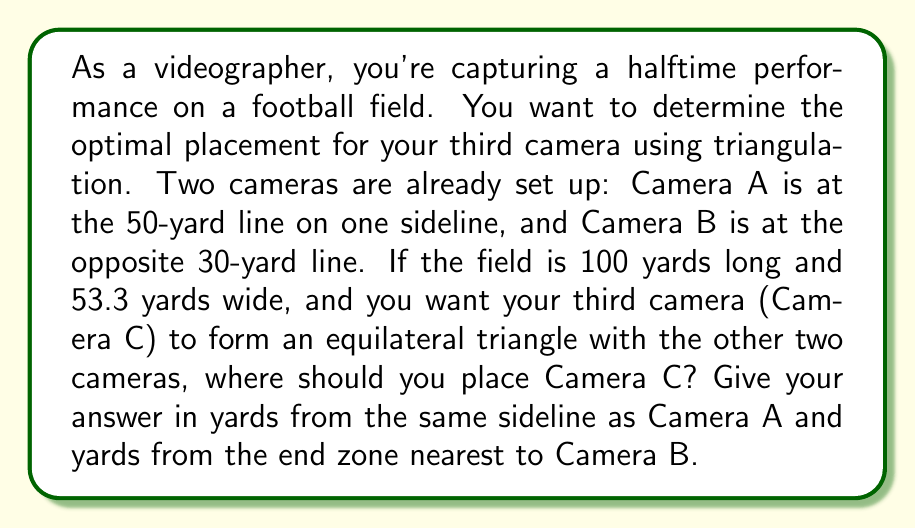Can you solve this math problem? Let's approach this step-by-step:

1) First, let's visualize the field and the cameras:

[asy]
unitsize(2.5mm);
draw((0,0)--(100,0)--(100,53.3)--(0,53.3)--cycle);
dot((50,0),red);
label("A",(50,0),S);
dot((70,53.3),red);
label("B",(70,53.3),N);
[/asy]

2) We need to find the distance between Camera A and Camera B. We can use the Pythagorean theorem:
   $$d = \sqrt{(70-50)^2 + 53.3^2} = \sqrt{400 + 2840.89} = \sqrt{3240.89} \approx 56.93$$yards

3) Since we want an equilateral triangle, Camera C should be the same distance from both A and B.

4) The perpendicular bisector of line AB will intersect the sideline at the point where Camera C should be placed.

5) Let's find the midpoint of AB:
   x-coordinate: $(50 + 70) / 2 = 60$
   y-coordinate: $(0 + 53.3) / 2 = 26.65$

6) The slope of AB is:
   $$m_{AB} = \frac{53.3 - 0}{70 - 50} = 2.665$$

7) The slope of the perpendicular bisector is the negative reciprocal:
   $$m_{perp} = -\frac{1}{2.665} \approx -0.3752$$

8) We can use the point-slope form of a line to find the equation of the perpendicular bisector:
   $$y - 26.65 = -0.3752(x - 60)$$

9) To find where this line intersects the sideline (y = 0), we solve:
   $$0 - 26.65 = -0.3752(x - 60)$$
   $$-26.65 = -0.3752x + 22.512$$
   $$-49.162 = -0.3752x$$
   $$x \approx 131.03$$

10) Therefore, Camera C should be placed approximately 131.03 yards from the end zone nearest to Camera B.

11) To find the distance from the sideline, we use the Pythagorean theorem again:
    $$\sqrt{56.93^2 - (131.03 - 70)^2} \approx 26.65$$ yards
Answer: Camera C should be placed approximately 131 yards from the end zone nearest to Camera B and 26.7 yards from the same sideline as Camera A. 